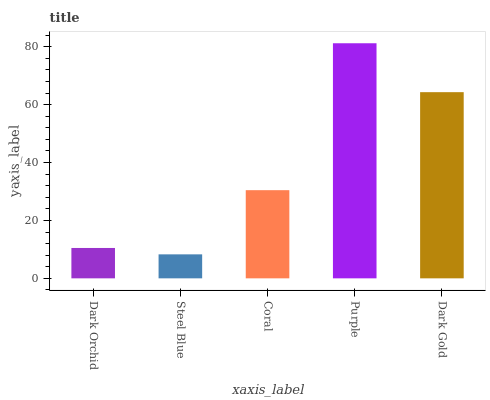Is Steel Blue the minimum?
Answer yes or no. Yes. Is Purple the maximum?
Answer yes or no. Yes. Is Coral the minimum?
Answer yes or no. No. Is Coral the maximum?
Answer yes or no. No. Is Coral greater than Steel Blue?
Answer yes or no. Yes. Is Steel Blue less than Coral?
Answer yes or no. Yes. Is Steel Blue greater than Coral?
Answer yes or no. No. Is Coral less than Steel Blue?
Answer yes or no. No. Is Coral the high median?
Answer yes or no. Yes. Is Coral the low median?
Answer yes or no. Yes. Is Dark Orchid the high median?
Answer yes or no. No. Is Purple the low median?
Answer yes or no. No. 